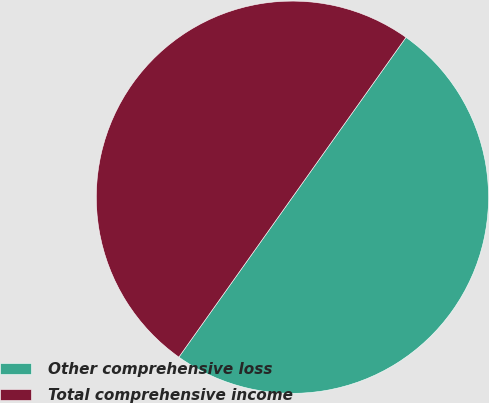<chart> <loc_0><loc_0><loc_500><loc_500><pie_chart><fcel>Other comprehensive loss<fcel>Total comprehensive income<nl><fcel>50.0%<fcel>50.0%<nl></chart> 